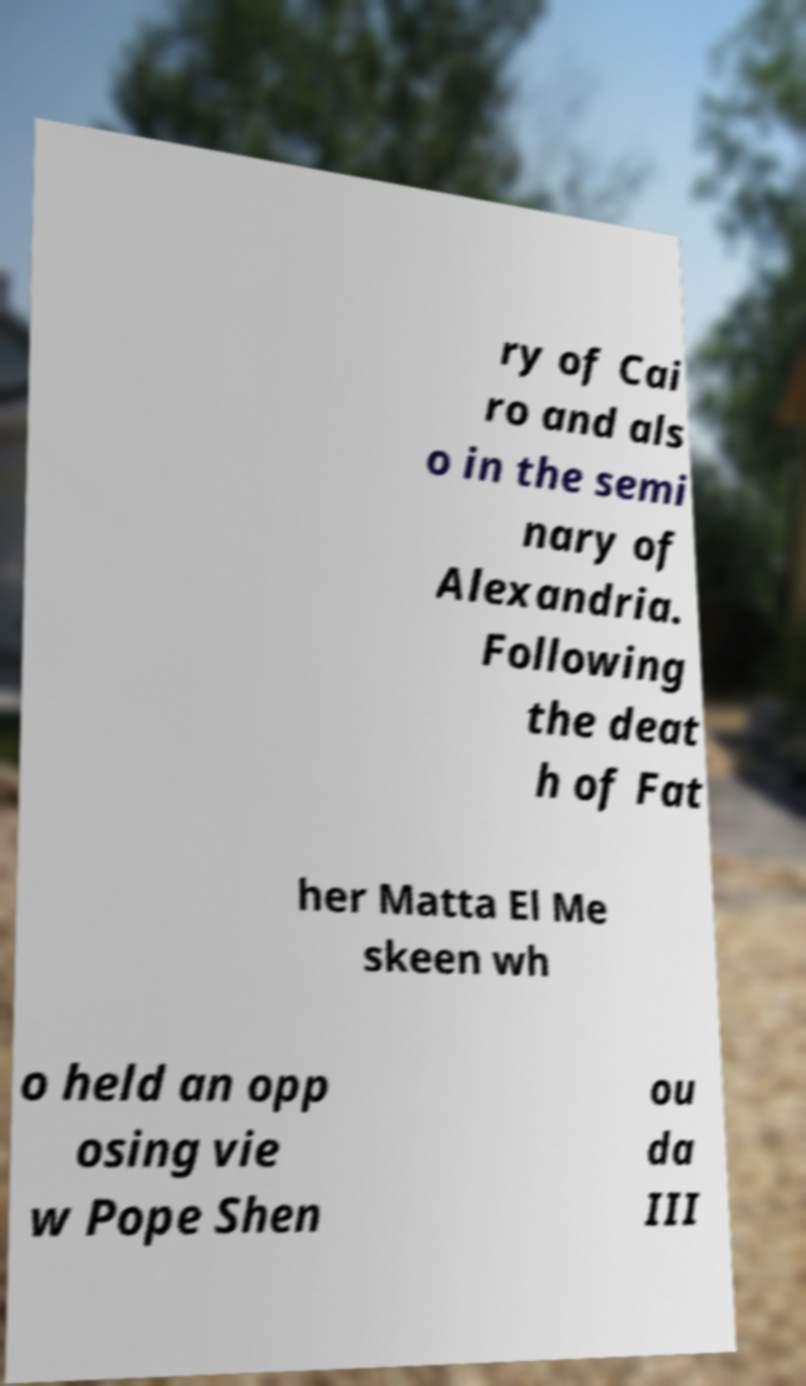Can you read and provide the text displayed in the image?This photo seems to have some interesting text. Can you extract and type it out for me? ry of Cai ro and als o in the semi nary of Alexandria. Following the deat h of Fat her Matta El Me skeen wh o held an opp osing vie w Pope Shen ou da III 